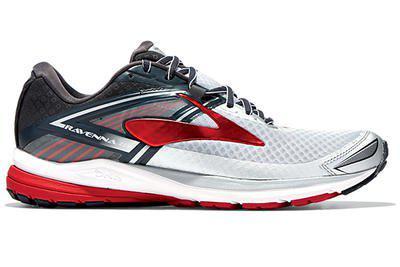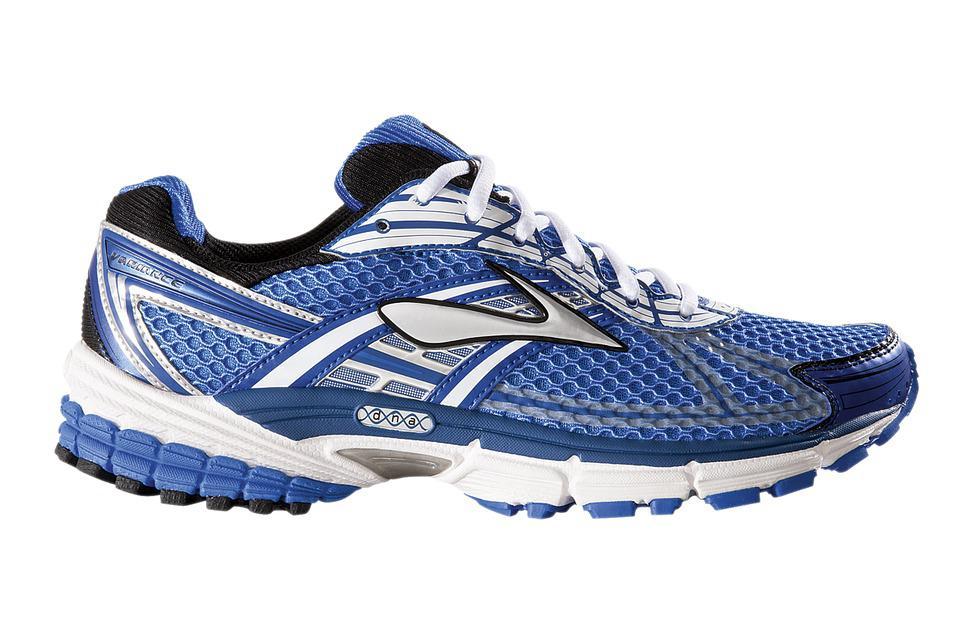The first image is the image on the left, the second image is the image on the right. Given the left and right images, does the statement "Exactly one shoe has a blue heel." hold true? Answer yes or no. Yes. 